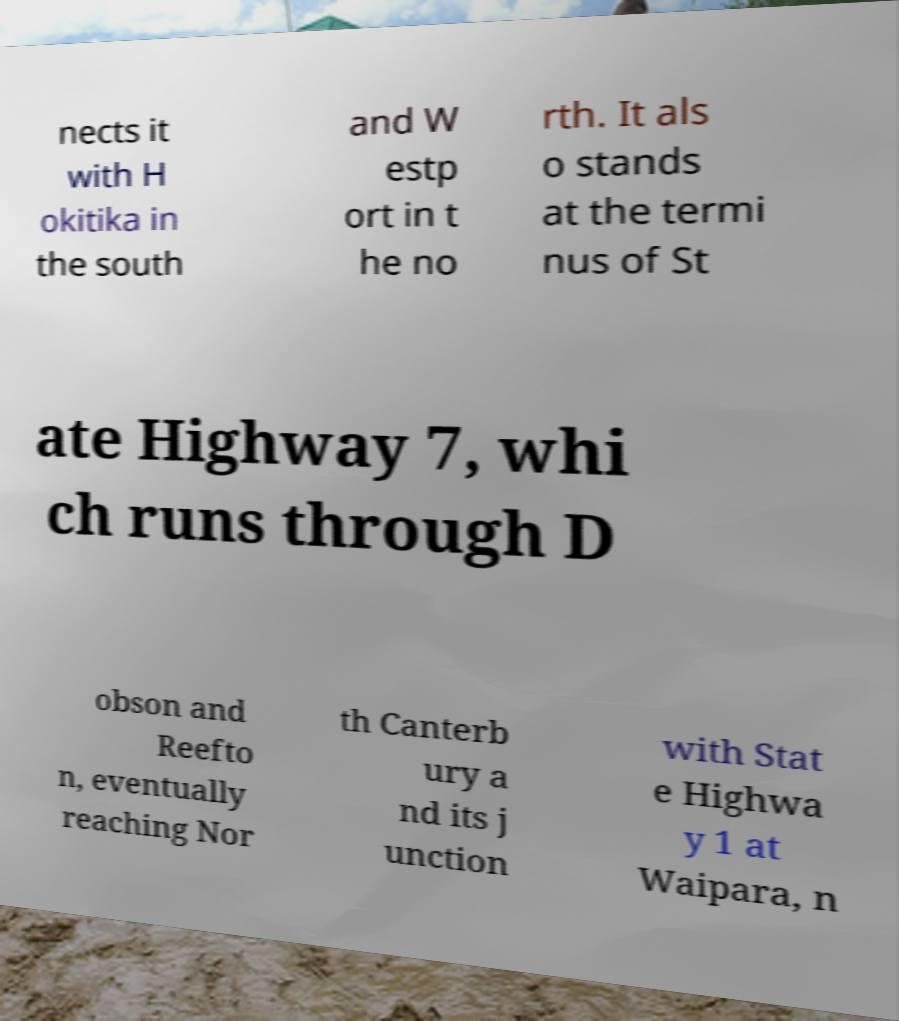Can you accurately transcribe the text from the provided image for me? nects it with H okitika in the south and W estp ort in t he no rth. It als o stands at the termi nus of St ate Highway 7, whi ch runs through D obson and Reefto n, eventually reaching Nor th Canterb ury a nd its j unction with Stat e Highwa y 1 at Waipara, n 